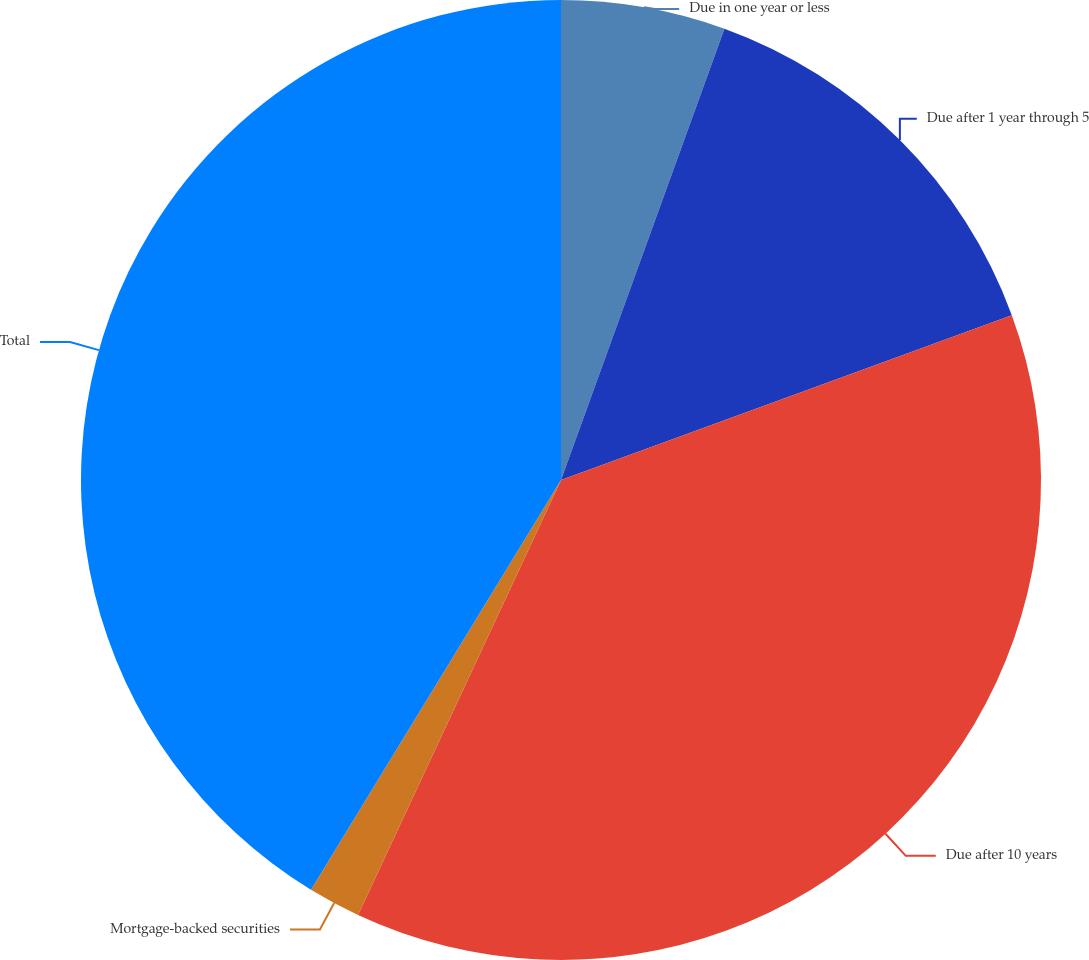Convert chart. <chart><loc_0><loc_0><loc_500><loc_500><pie_chart><fcel>Due in one year or less<fcel>Due after 1 year through 5<fcel>Due after 10 years<fcel>Mortgage-backed securities<fcel>Total<nl><fcel>5.53%<fcel>13.89%<fcel>37.53%<fcel>1.77%<fcel>41.28%<nl></chart> 